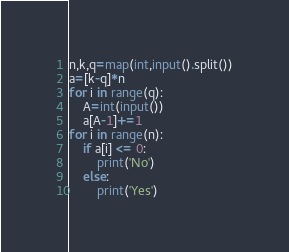Convert code to text. <code><loc_0><loc_0><loc_500><loc_500><_Python_>n,k,q=map(int,input().split())
a=[k-q]*n
for i in range(q):
    A=int(input())
    a[A-1]+=1
for i in range(n):
    if a[i] <= 0:
        print('No')
    else:
        print('Yes')
</code> 